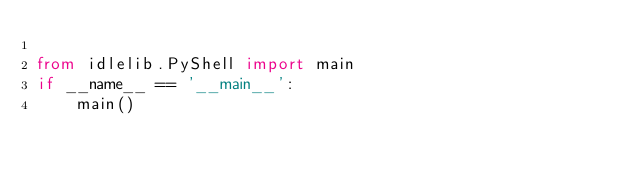Convert code to text. <code><loc_0><loc_0><loc_500><loc_500><_Python_>
from idlelib.PyShell import main
if __name__ == '__main__':
    main()
</code> 